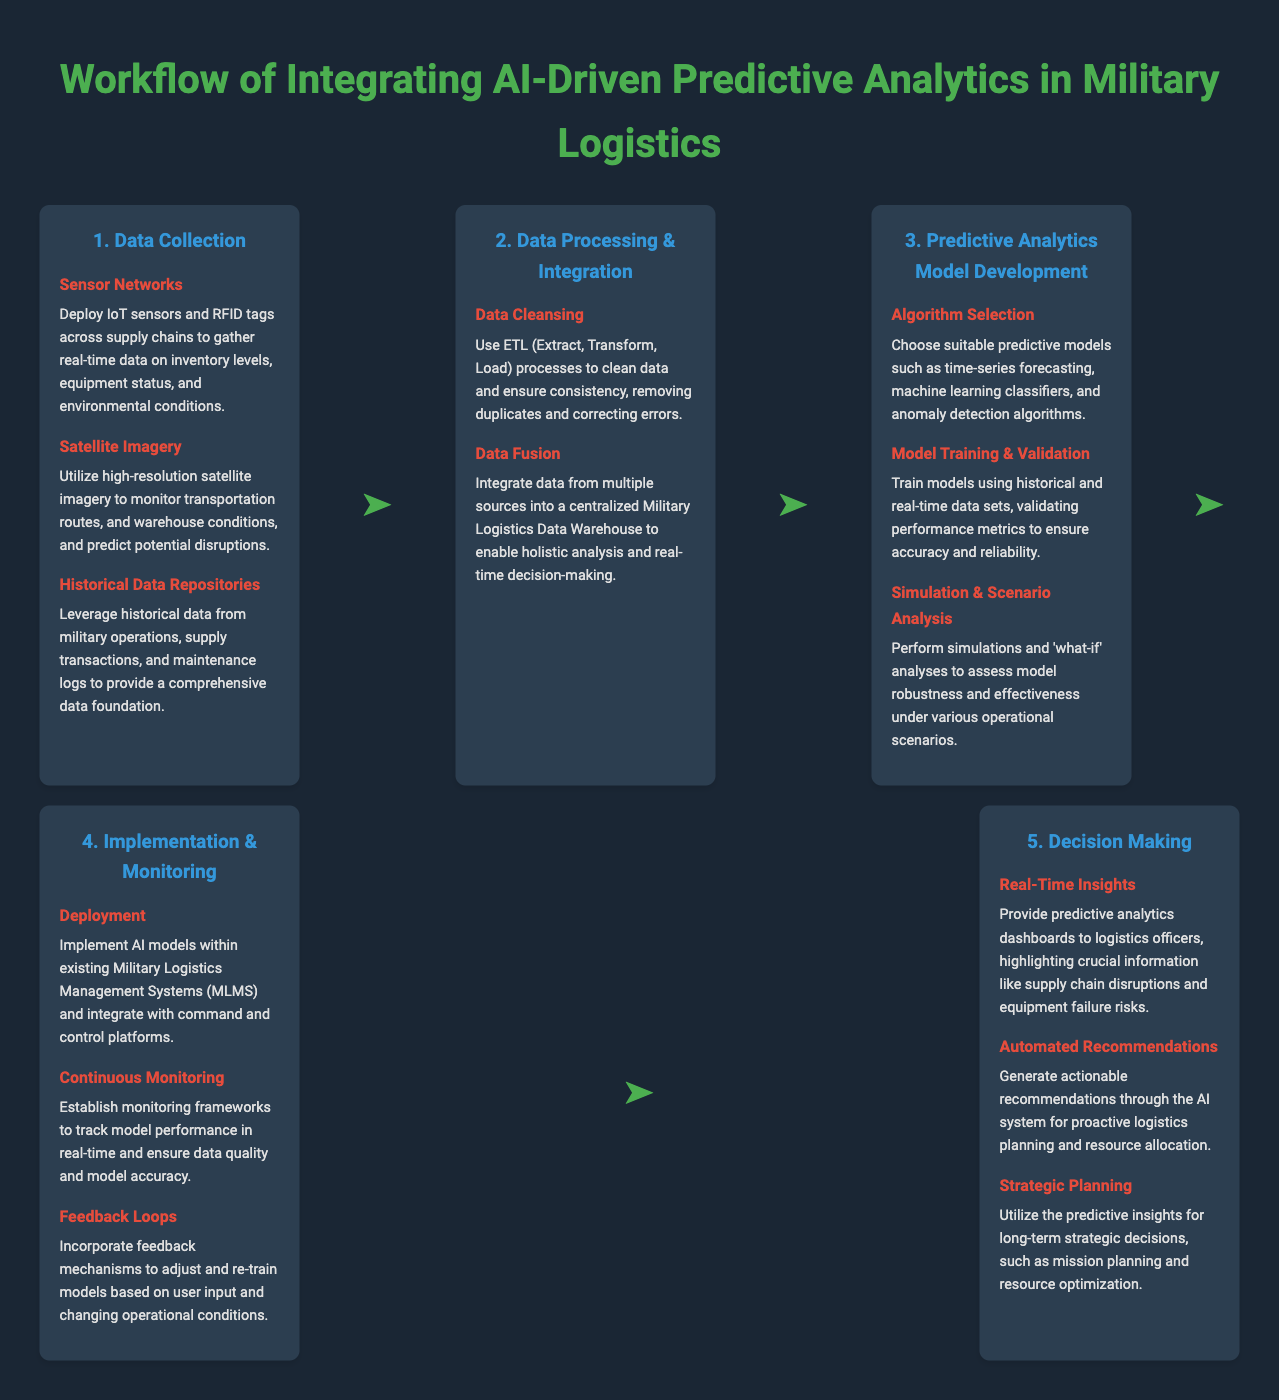what is the first step in the workflow? The first step in the workflow is listed in the document and is "Data Collection."
Answer: Data Collection what technology is used for real-time data gathering? The document specifies "IoT sensors and RFID tags" as technologies for real-time data gathering.
Answer: IoT sensors and RFID tags which type of model is chosen during the predictive analytics model development? The document mentions "time-series forecasting, machine learning classifiers, and anomaly detection algorithms" as types of models selected.
Answer: time-series forecasting, machine learning classifiers, and anomaly detection algorithms how many main sections are in the workflow? The document outlines five main sections in the workflow, each representing a distinct stage.
Answer: 5 what is established for tracking model performance? The document indicates that "monitoring frameworks" are established for tracking model performance.
Answer: monitoring frameworks what mechanism is used to adapt models based on conditions? The document states that "feedback loops" are the mechanisms incorporated to adapt models based on changing conditions.
Answer: feedback loops which step includes simulations and scenario analyses? The document specifies "Predictive Analytics Model Development" as the step that includes simulations and scenario analyses.
Answer: Predictive Analytics Model Development what type of insights do predictive analytics dashboards provide? According to the document, the dashboards provide "real-time insights" regarding logistics operations.
Answer: real-time insights 